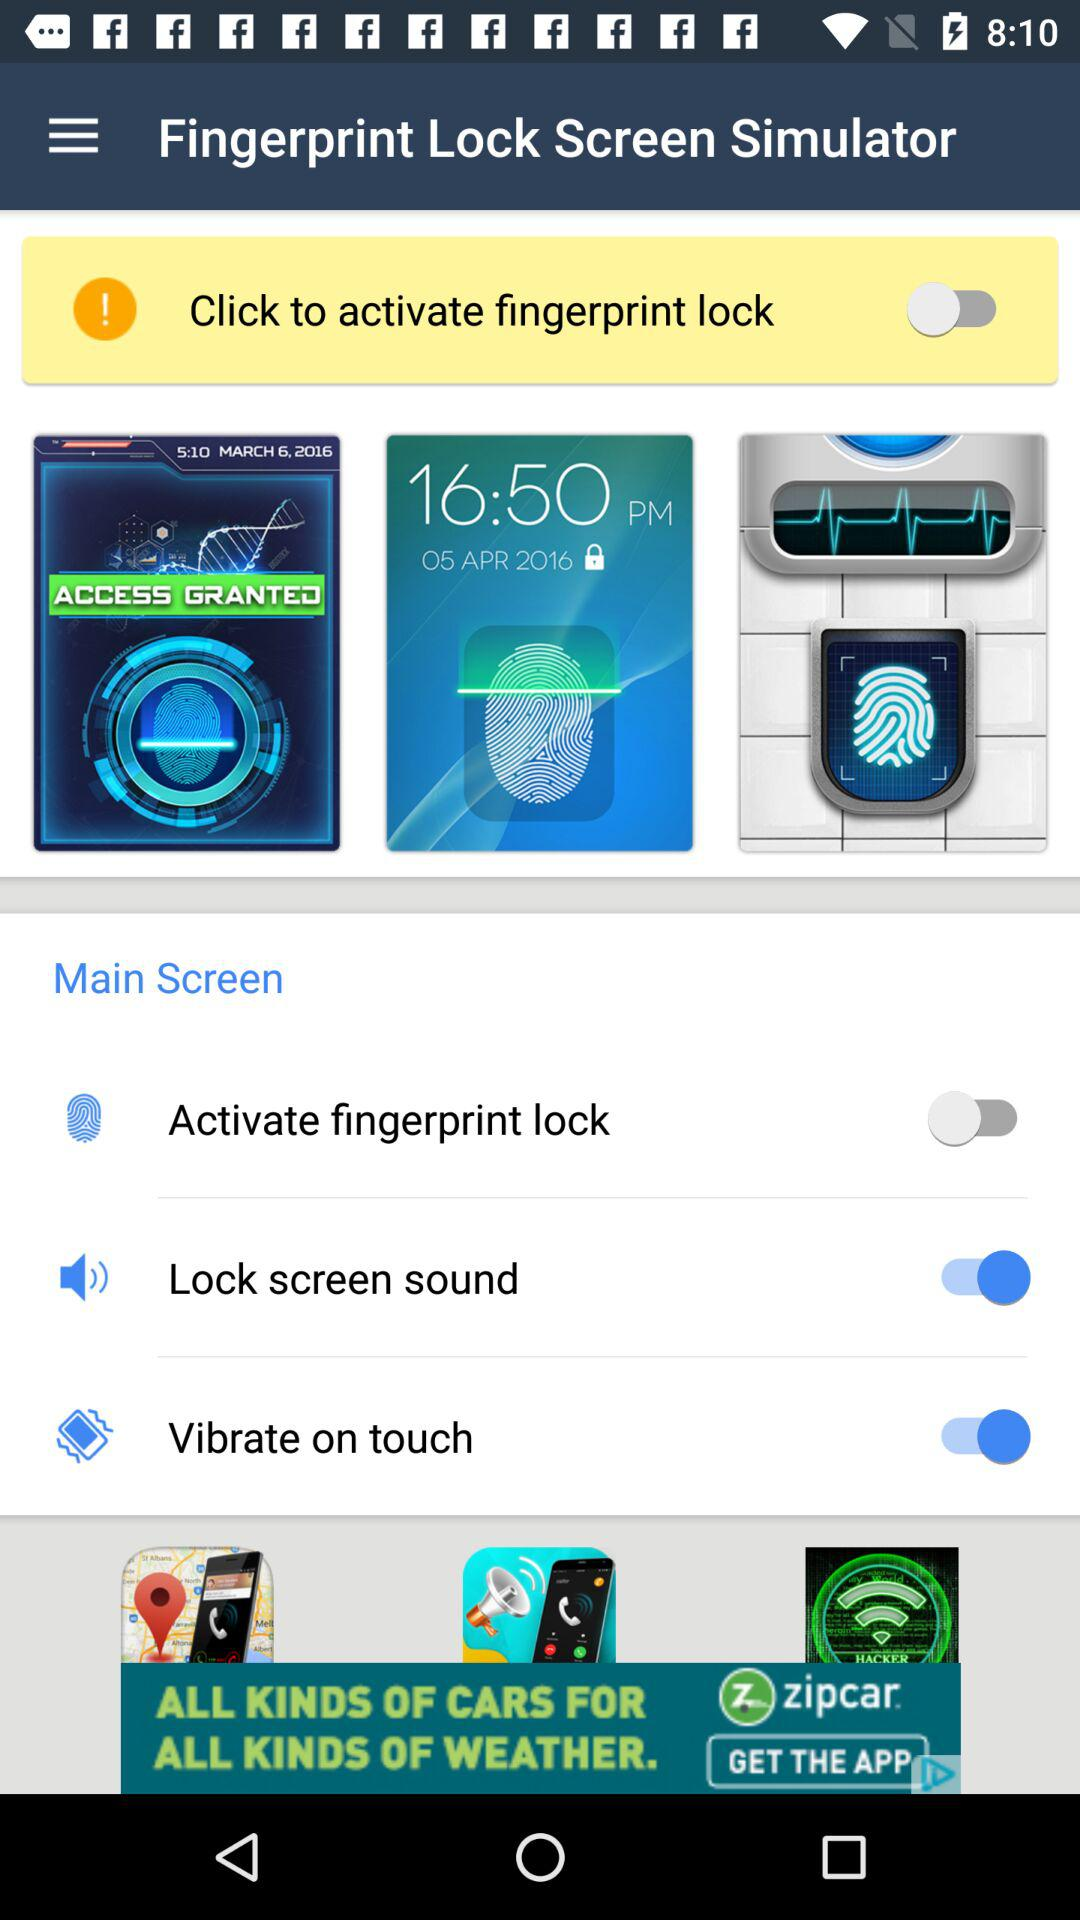Which options are enabled in the main screen? The enabled options in the main screen are "Lock screen sound" and "Vibrate on touch". 